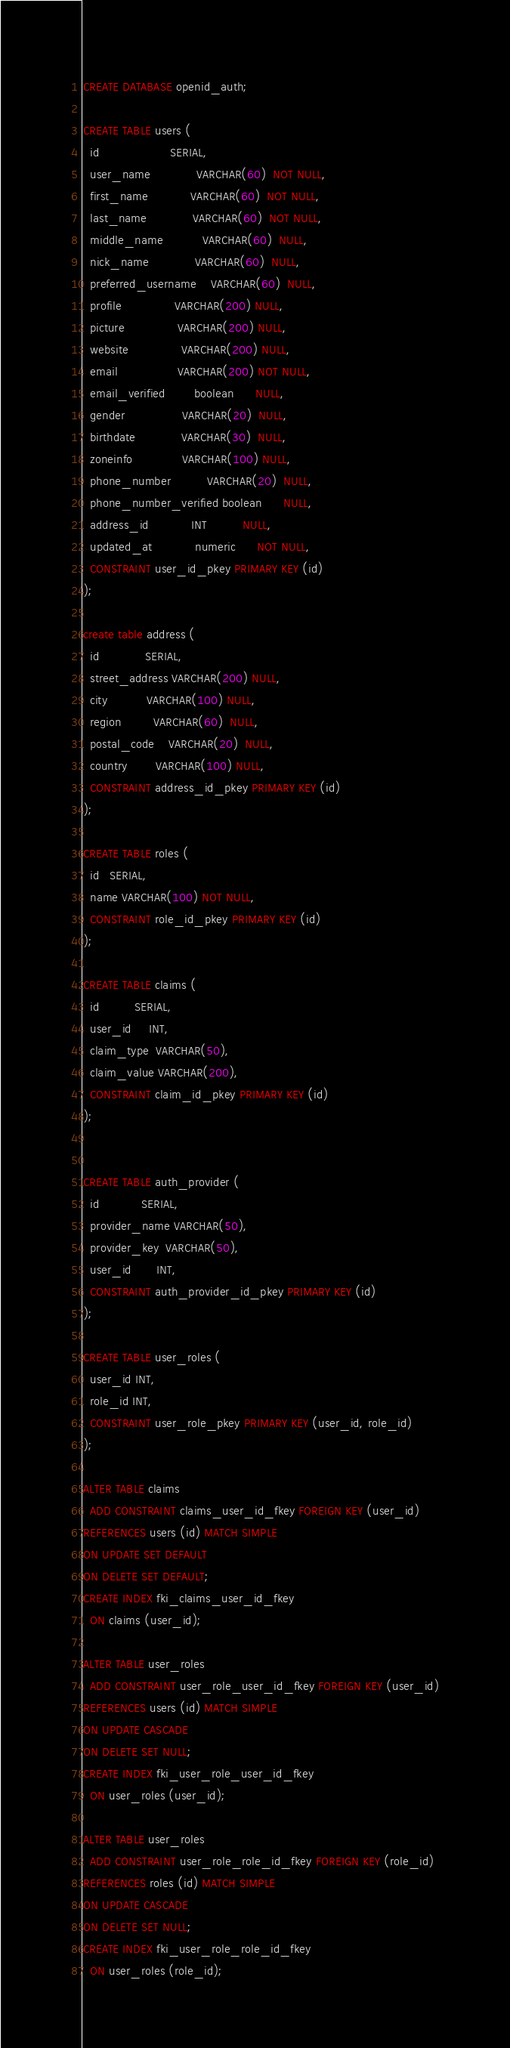Convert code to text. <code><loc_0><loc_0><loc_500><loc_500><_SQL_>CREATE DATABASE openid_auth;

CREATE TABLE users (
  id                    SERIAL,
  user_name             VARCHAR(60)  NOT NULL,
  first_name            VARCHAR(60)  NOT NULL,
  last_name             VARCHAR(60)  NOT NULL,
  middle_name           VARCHAR(60)  NULL,
  nick_name             VARCHAR(60)  NULL,
  preferred_username    VARCHAR(60)  NULL,
  profile               VARCHAR(200) NULL,
  picture               VARCHAR(200) NULL,
  website               VARCHAR(200) NULL,
  email                 VARCHAR(200) NOT NULL,
  email_verified        boolean      NULL,
  gender                VARCHAR(20)  NULL,
  birthdate             VARCHAR(30)  NULL,
  zoneinfo              VARCHAR(100) NULL,
  phone_number          VARCHAR(20)  NULL,
  phone_number_verified boolean      NULL,
  address_id            INT          NULL,
  updated_at            numeric      NOT NULL,
  CONSTRAINT user_id_pkey PRIMARY KEY (id)
);

create table address (
  id             SERIAL,
  street_address VARCHAR(200) NULL,
  city           VARCHAR(100) NULL,
  region         VARCHAR(60)  NULL,
  postal_code    VARCHAR(20)  NULL,
  country        VARCHAR(100) NULL,
  CONSTRAINT address_id_pkey PRIMARY KEY (id)
);

CREATE TABLE roles (
  id   SERIAL,
  name VARCHAR(100) NOT NULL,
  CONSTRAINT role_id_pkey PRIMARY KEY (id)
);

CREATE TABLE claims (
  id          SERIAL,
  user_id     INT,
  claim_type  VARCHAR(50),
  claim_value VARCHAR(200),
  CONSTRAINT claim_id_pkey PRIMARY KEY (id)
);


CREATE TABLE auth_provider (
  id            SERIAL,
  provider_name VARCHAR(50),
  provider_key  VARCHAR(50),
  user_id       INT,
  CONSTRAINT auth_provider_id_pkey PRIMARY KEY (id)
);

CREATE TABLE user_roles (
  user_id INT,
  role_id INT,
  CONSTRAINT user_role_pkey PRIMARY KEY (user_id, role_id)
);

ALTER TABLE claims
  ADD CONSTRAINT claims_user_id_fkey FOREIGN KEY (user_id)
REFERENCES users (id) MATCH SIMPLE
ON UPDATE SET DEFAULT
ON DELETE SET DEFAULT;
CREATE INDEX fki_claims_user_id_fkey
  ON claims (user_id);

ALTER TABLE user_roles
  ADD CONSTRAINT user_role_user_id_fkey FOREIGN KEY (user_id)
REFERENCES users (id) MATCH SIMPLE
ON UPDATE CASCADE
ON DELETE SET NULL;
CREATE INDEX fki_user_role_user_id_fkey
  ON user_roles (user_id);

ALTER TABLE user_roles
  ADD CONSTRAINT user_role_role_id_fkey FOREIGN KEY (role_id)
REFERENCES roles (id) MATCH SIMPLE
ON UPDATE CASCADE
ON DELETE SET NULL;
CREATE INDEX fki_user_role_role_id_fkey
  ON user_roles (role_id);</code> 